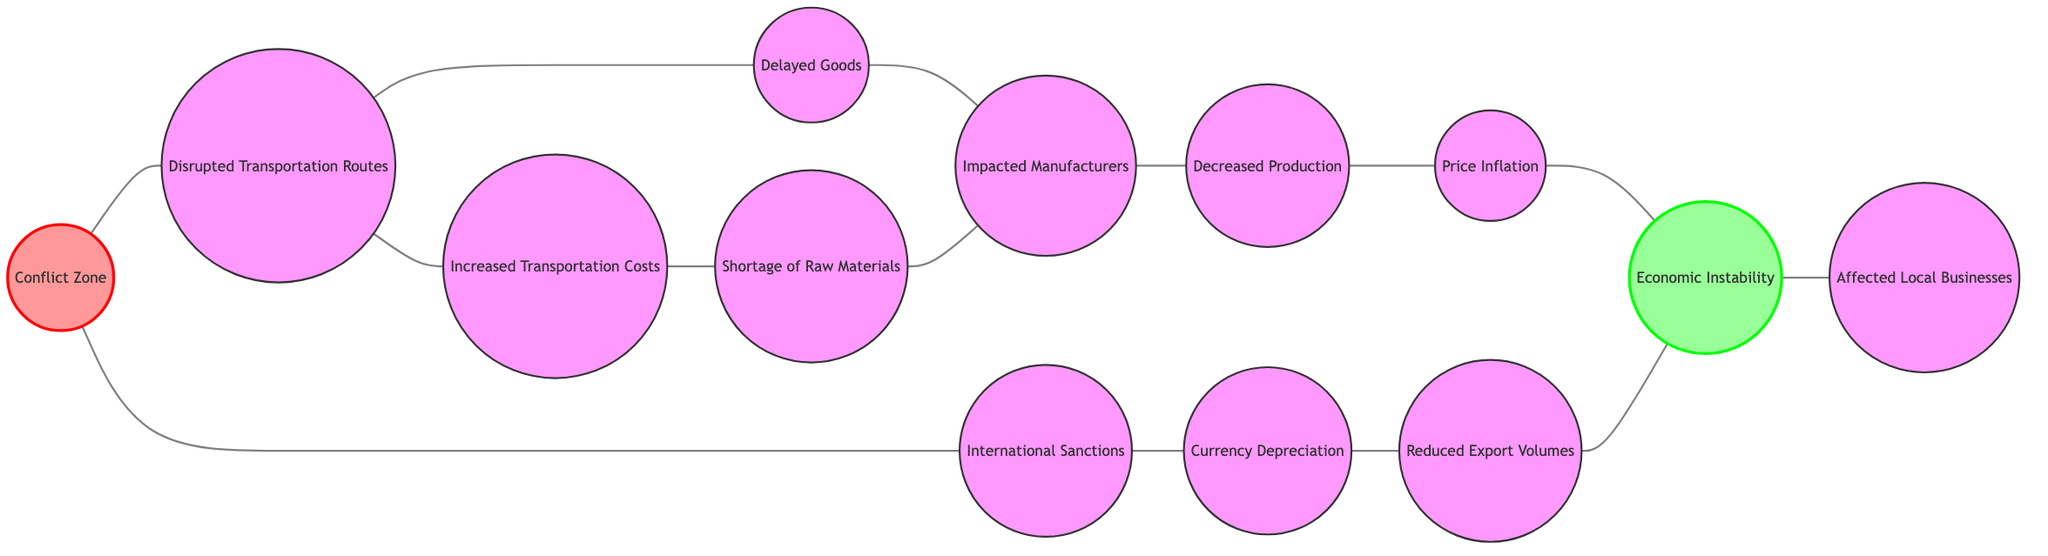What is the total number of nodes in the diagram? Counting the nodes listed in the data, there are 13 distinct entities represented, each corresponding to a specific aspect of supply chain disruptions due to conflict.
Answer: 13 What do nodes 1 and 2 represent? Node 1 represents "Conflict Zone," indicating the area affected by warfare, while node 2 represents "Disrupted Transportation Routes," signifying the impact on logistics due to the conflict.
Answer: Conflict Zone and Disrupted Transportation Routes Which node is directly connected to "Increased Transportation Costs"? Node 4, labeled "Increased Transportation Costs," is directly connected to two nodes: node 2 (Disrupted Transportation Routes) and node 5 (Shortage of Raw Materials). This is evident from the edges displayed in the diagram.
Answer: Disrupted Transportation Routes and Shortage of Raw Materials What is the relationship between “Decreased Production” and “Price Inflation”? There is a direct connection from node 7 ("Decreased Production") to node 8 ("Price Inflation"), indicating that as production decreases, prices tend to rise, likely due to scarcity.
Answer: Affected by each other How does "International Sanctions" affect "Currency Depreciation"? "International Sanctions," represented by node 11, directly leads to "Currency Depreciation," as shown by the edge connecting these two nodes, indicating sanctions can lead to a decline in currency value.
Answer: Direct connection What nodes are affected by "Economic Instability"? "Economic Instability," represented by node 9, is directly connected to nodes 10 (Affected Local Businesses) and also connects indirectly through nodes leading to it; thus, all nodes in the diagram connect back to this main node.
Answer: Affected Local Businesses What is the flow from "Shortage of Raw Materials" to "Decreased Production"? The flow begins at node 5 ("Shortage of Raw Materials"), which connects to node 6 ("Impacted Manufacturers"), and then leads to node 7 ("Decreased Production"), showing that the lack of materials impacts production capacity.
Answer: Shortage of Raw Materials to Decreased Production How many edges connect to "Delayed Goods"? Node 3 ("Delayed Goods") has one direct connection to node 2 ("Disrupted Transportation Routes") and one connection to node 6 ("Impacted Manufacturers"), totaling two edges linked to this node.
Answer: 2 What happens to "Reduced Export Volumes" as a result of "Currency Depreciation"? There's a direct path from node 12 ("Currency Depreciation") to node 13 ("Reduced Export Volumes"), indicating that depreciation of the currency leads to a decline in export volumes due to increased cost of exports in foreign markets.
Answer: Reduced Export Volumes 